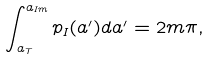<formula> <loc_0><loc_0><loc_500><loc_500>\int _ { a _ { T } } ^ { a _ { I m } } p _ { I } ( a ^ { \prime } ) d a ^ { \prime } = 2 m \pi ,</formula> 